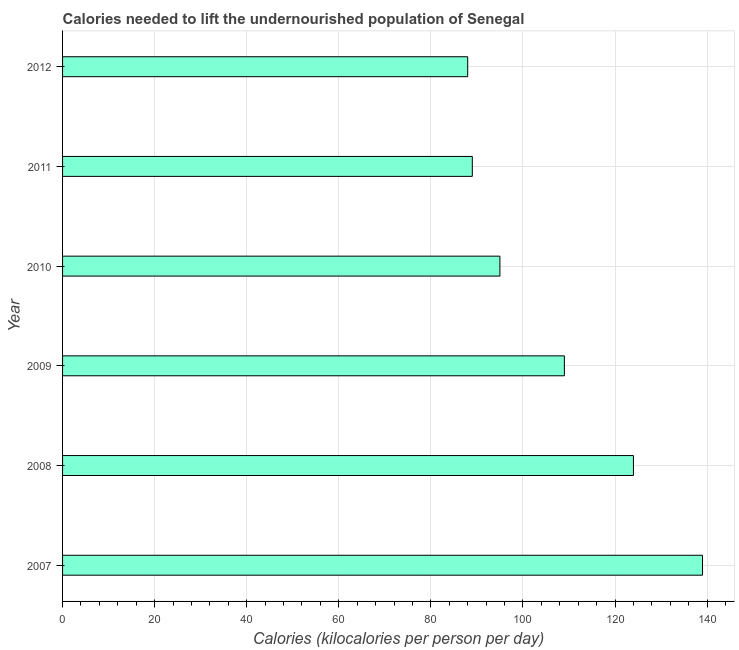Does the graph contain grids?
Ensure brevity in your answer.  Yes. What is the title of the graph?
Your answer should be compact. Calories needed to lift the undernourished population of Senegal. What is the label or title of the X-axis?
Keep it short and to the point. Calories (kilocalories per person per day). What is the depth of food deficit in 2010?
Your answer should be very brief. 95. Across all years, what is the maximum depth of food deficit?
Your answer should be very brief. 139. Across all years, what is the minimum depth of food deficit?
Offer a terse response. 88. In which year was the depth of food deficit maximum?
Your response must be concise. 2007. In which year was the depth of food deficit minimum?
Offer a very short reply. 2012. What is the sum of the depth of food deficit?
Make the answer very short. 644. What is the average depth of food deficit per year?
Offer a terse response. 107. What is the median depth of food deficit?
Give a very brief answer. 102. What is the ratio of the depth of food deficit in 2009 to that in 2012?
Offer a terse response. 1.24. Is the depth of food deficit in 2007 less than that in 2011?
Give a very brief answer. No. What is the difference between the highest and the lowest depth of food deficit?
Provide a short and direct response. 51. In how many years, is the depth of food deficit greater than the average depth of food deficit taken over all years?
Make the answer very short. 3. Are all the bars in the graph horizontal?
Keep it short and to the point. Yes. What is the difference between two consecutive major ticks on the X-axis?
Offer a terse response. 20. Are the values on the major ticks of X-axis written in scientific E-notation?
Keep it short and to the point. No. What is the Calories (kilocalories per person per day) in 2007?
Your answer should be compact. 139. What is the Calories (kilocalories per person per day) of 2008?
Keep it short and to the point. 124. What is the Calories (kilocalories per person per day) of 2009?
Offer a very short reply. 109. What is the Calories (kilocalories per person per day) of 2010?
Make the answer very short. 95. What is the Calories (kilocalories per person per day) in 2011?
Offer a very short reply. 89. What is the difference between the Calories (kilocalories per person per day) in 2007 and 2009?
Offer a terse response. 30. What is the difference between the Calories (kilocalories per person per day) in 2007 and 2010?
Offer a very short reply. 44. What is the difference between the Calories (kilocalories per person per day) in 2007 and 2011?
Your answer should be very brief. 50. What is the difference between the Calories (kilocalories per person per day) in 2007 and 2012?
Provide a short and direct response. 51. What is the difference between the Calories (kilocalories per person per day) in 2008 and 2010?
Provide a short and direct response. 29. What is the difference between the Calories (kilocalories per person per day) in 2008 and 2011?
Make the answer very short. 35. What is the difference between the Calories (kilocalories per person per day) in 2008 and 2012?
Your answer should be very brief. 36. What is the difference between the Calories (kilocalories per person per day) in 2010 and 2012?
Your answer should be very brief. 7. What is the difference between the Calories (kilocalories per person per day) in 2011 and 2012?
Offer a very short reply. 1. What is the ratio of the Calories (kilocalories per person per day) in 2007 to that in 2008?
Ensure brevity in your answer.  1.12. What is the ratio of the Calories (kilocalories per person per day) in 2007 to that in 2009?
Offer a very short reply. 1.27. What is the ratio of the Calories (kilocalories per person per day) in 2007 to that in 2010?
Your response must be concise. 1.46. What is the ratio of the Calories (kilocalories per person per day) in 2007 to that in 2011?
Provide a succinct answer. 1.56. What is the ratio of the Calories (kilocalories per person per day) in 2007 to that in 2012?
Ensure brevity in your answer.  1.58. What is the ratio of the Calories (kilocalories per person per day) in 2008 to that in 2009?
Your response must be concise. 1.14. What is the ratio of the Calories (kilocalories per person per day) in 2008 to that in 2010?
Provide a succinct answer. 1.3. What is the ratio of the Calories (kilocalories per person per day) in 2008 to that in 2011?
Give a very brief answer. 1.39. What is the ratio of the Calories (kilocalories per person per day) in 2008 to that in 2012?
Your answer should be very brief. 1.41. What is the ratio of the Calories (kilocalories per person per day) in 2009 to that in 2010?
Keep it short and to the point. 1.15. What is the ratio of the Calories (kilocalories per person per day) in 2009 to that in 2011?
Offer a terse response. 1.23. What is the ratio of the Calories (kilocalories per person per day) in 2009 to that in 2012?
Your response must be concise. 1.24. What is the ratio of the Calories (kilocalories per person per day) in 2010 to that in 2011?
Offer a terse response. 1.07. 